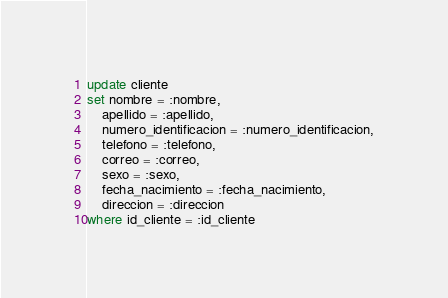Convert code to text. <code><loc_0><loc_0><loc_500><loc_500><_SQL_>update cliente
set nombre = :nombre,
    apellido = :apellido,
    numero_identificacion = :numero_identificacion,
    telefono = :telefono,
    correo = :correo,
    sexo = :sexo,
    fecha_nacimiento = :fecha_nacimiento,
    direccion = :direccion
where id_cliente = :id_cliente</code> 